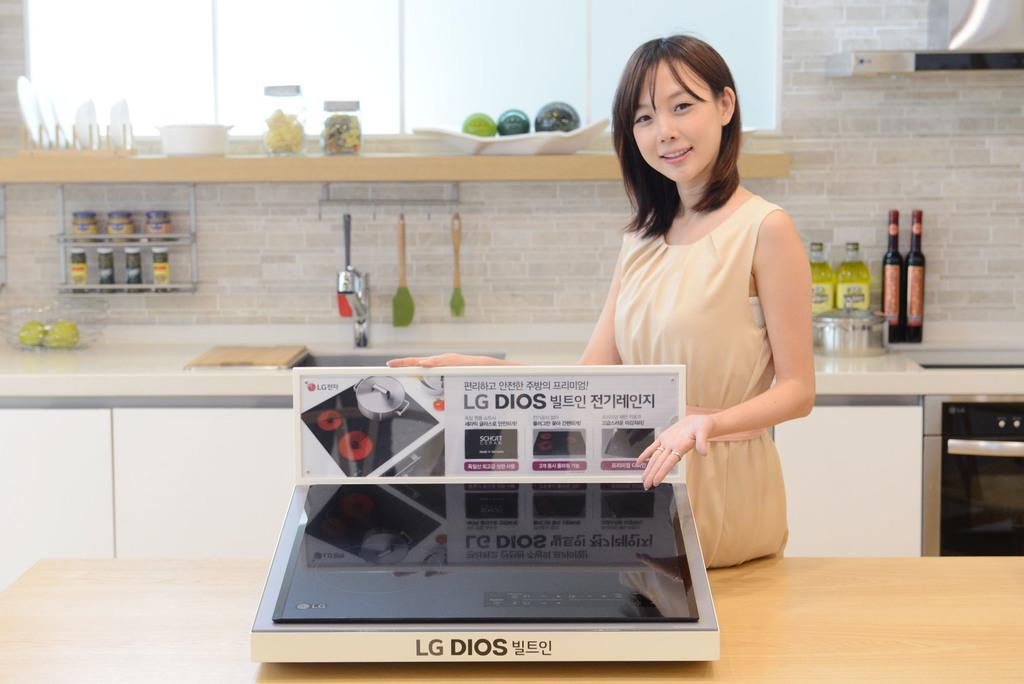<image>
Share a concise interpretation of the image provided. a woman standing in front of a lg dios stovetop 